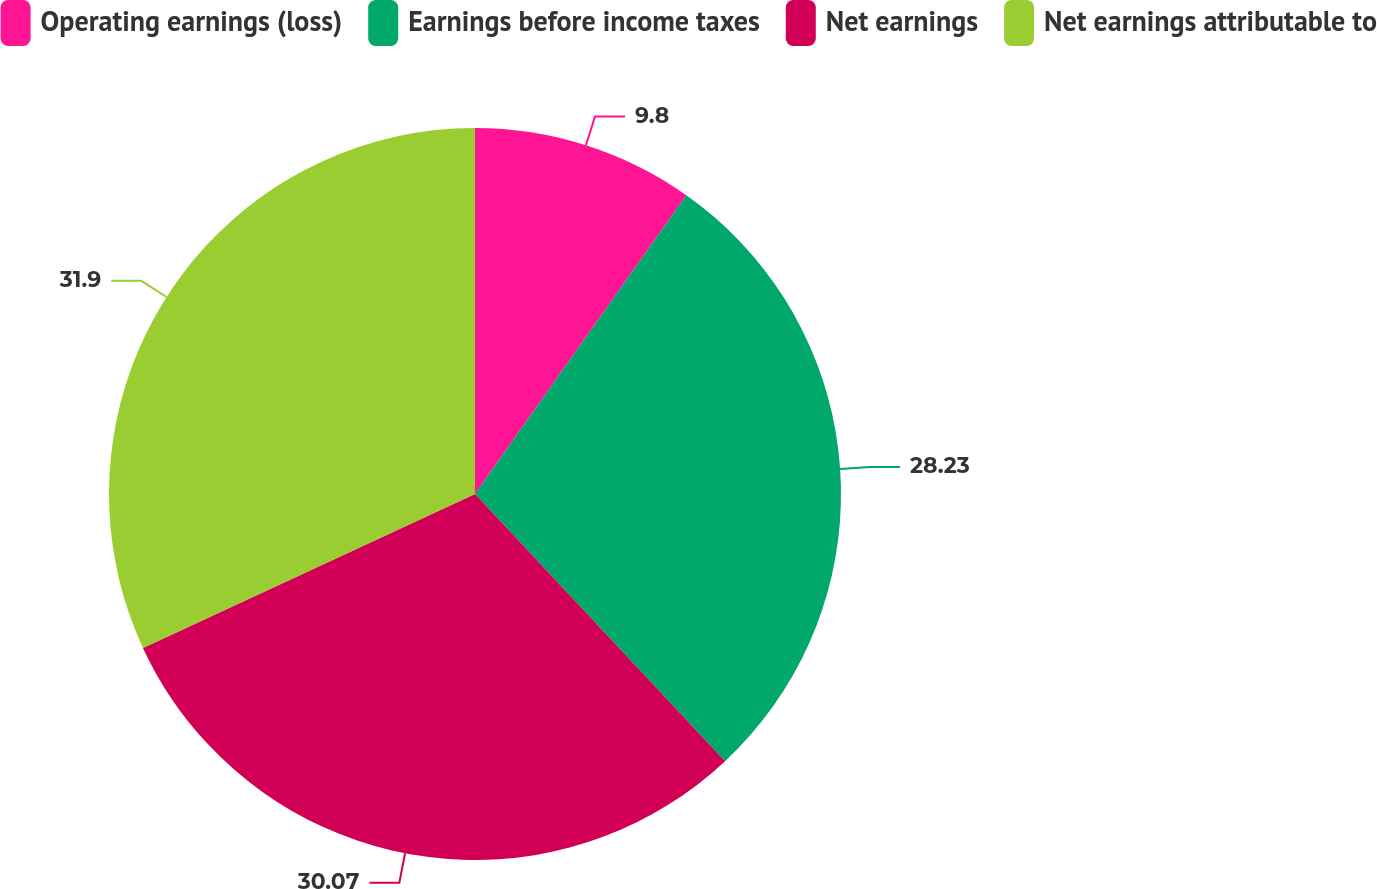Convert chart to OTSL. <chart><loc_0><loc_0><loc_500><loc_500><pie_chart><fcel>Operating earnings (loss)<fcel>Earnings before income taxes<fcel>Net earnings<fcel>Net earnings attributable to<nl><fcel>9.8%<fcel>28.23%<fcel>30.07%<fcel>31.91%<nl></chart> 